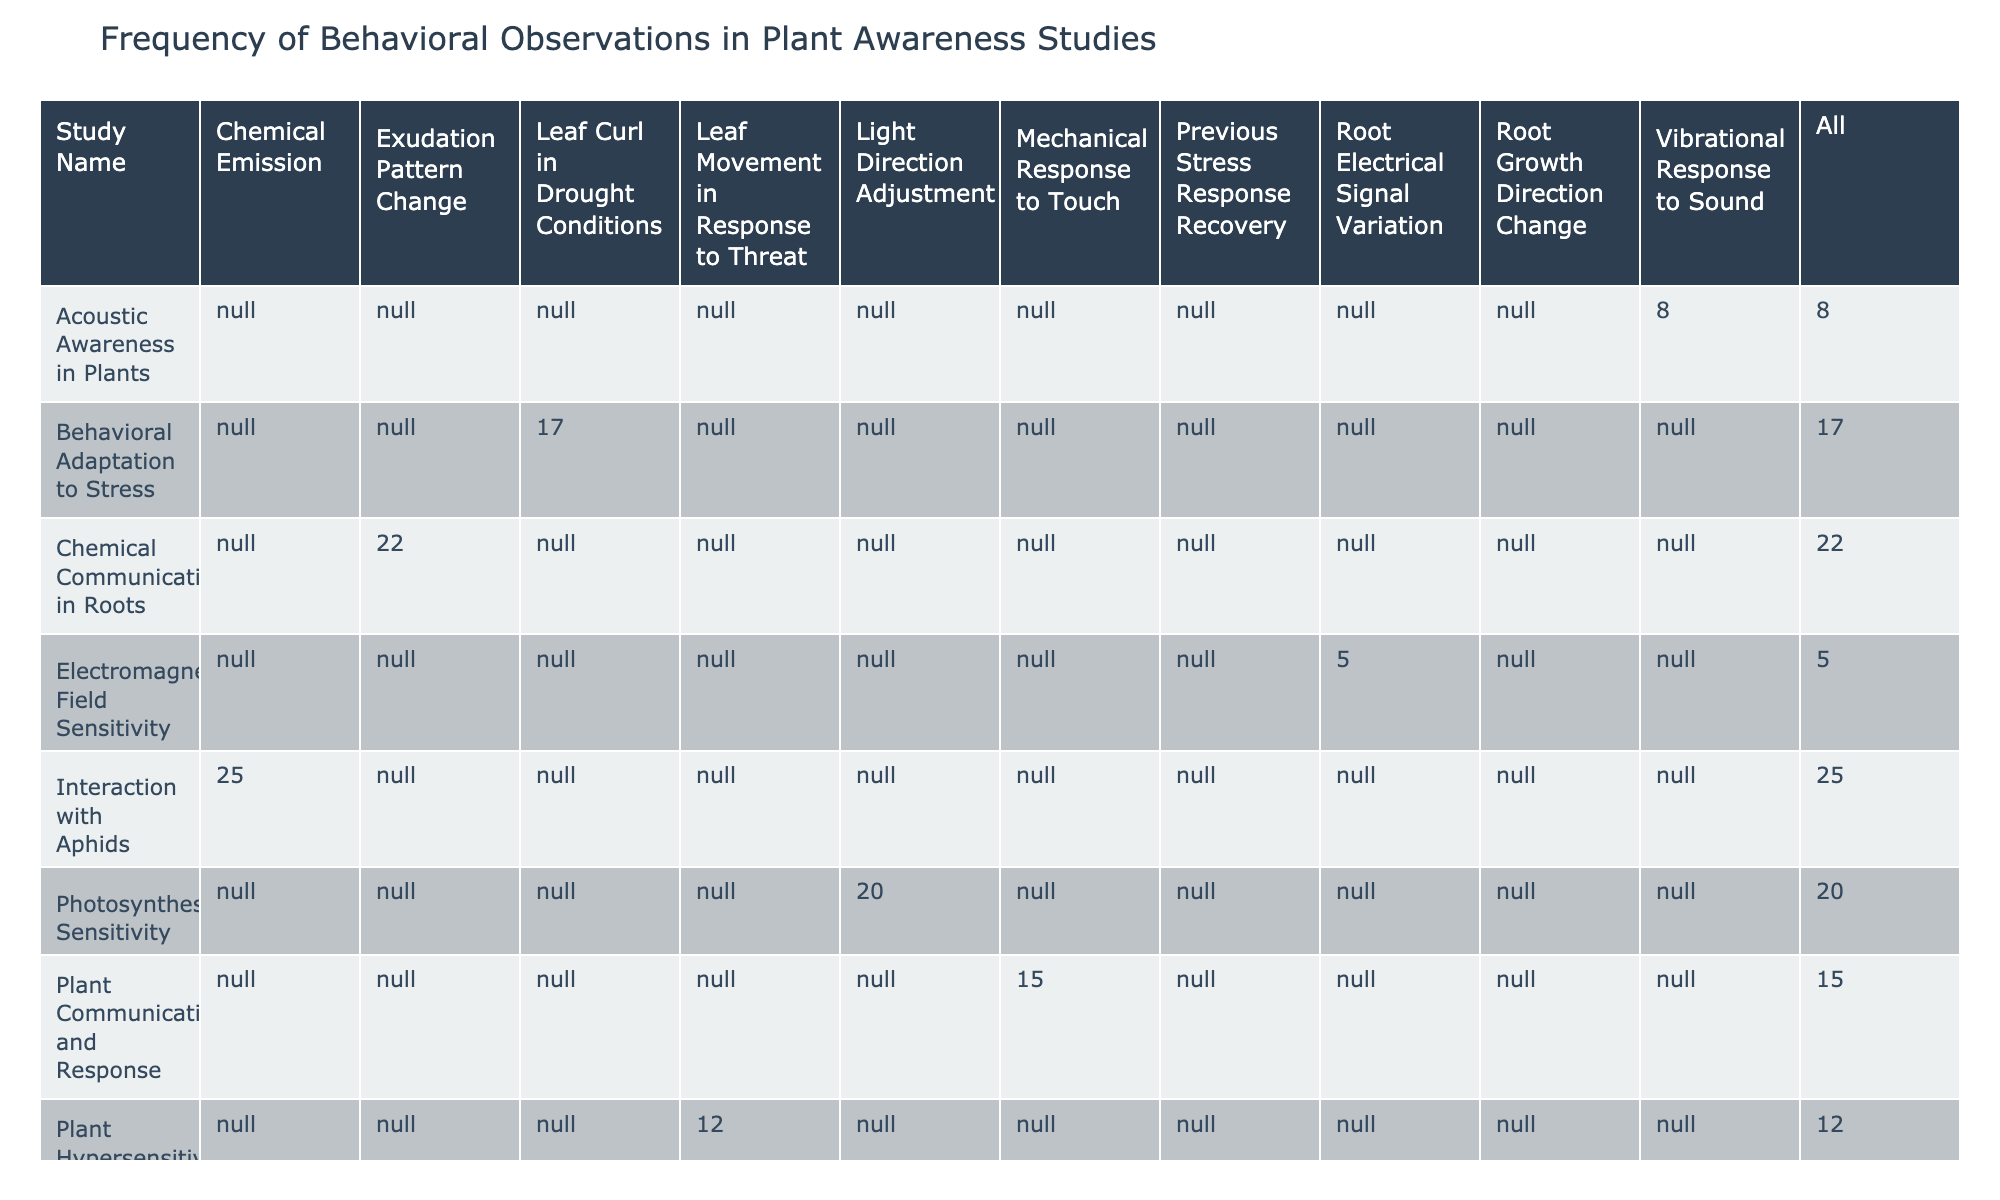What is the observation frequency for "Chemical Emission"? The table lists "Chemical Emission" under the behavior observed for the study "Interaction with Aphids" with an observation frequency of 25.
Answer: 25 Which study has the highest observation frequency? To find the highest observation frequency, we look through the values: 15, 20, 10, 25, 12, 8, 5, 18, 22, 17. The highest value is 25 from the study "Interaction with Aphids."
Answer: Interaction with Aphids How many studies recorded a frequency greater than 15? We will count the frequencies that are greater than 15: 20, 25, 22, and 18 appear four times. Thus, there are four studies with a frequency greater than 15.
Answer: 4 What is the average observation frequency across all studies? First, we sum up the observation frequencies: 15 + 20 + 10 + 25 + 12 + 8 + 5 + 18 + 22 + 17 = 142. There are 10 studies, so the average is 142/10 = 14.2.
Answer: 14.2 Did any study record a behavior labeled "Leaf Movement in Response to Threat"? We check the table for the specific behavior "Leaf Movement in Response to Threat," which is listed under the study "Plant Hypersensitivity." Therefore, the answer is yes.
Answer: Yes What is the total observation frequency for "Root Growth Direction Change" and "Leaf Curl in Drought Conditions"? We find "Root Growth Direction Change" with a frequency of 10 and "Leaf Curl in Drought Conditions" with a frequency of 17. Adding these gives 10 + 17 = 27.
Answer: 27 How many behaviors had an observation frequency less than 10? Checking the table, only "Acoustic Awareness in Plants" has a frequency of 8, which is the only value below 10, so there is 1 study.
Answer: 1 Which study observed the "Vibrational Response to Sound"? We look for the behavior "Vibrational Response to Sound" and find it under the study "Acoustic Awareness in Plants."
Answer: Acoustic Awareness in Plants 